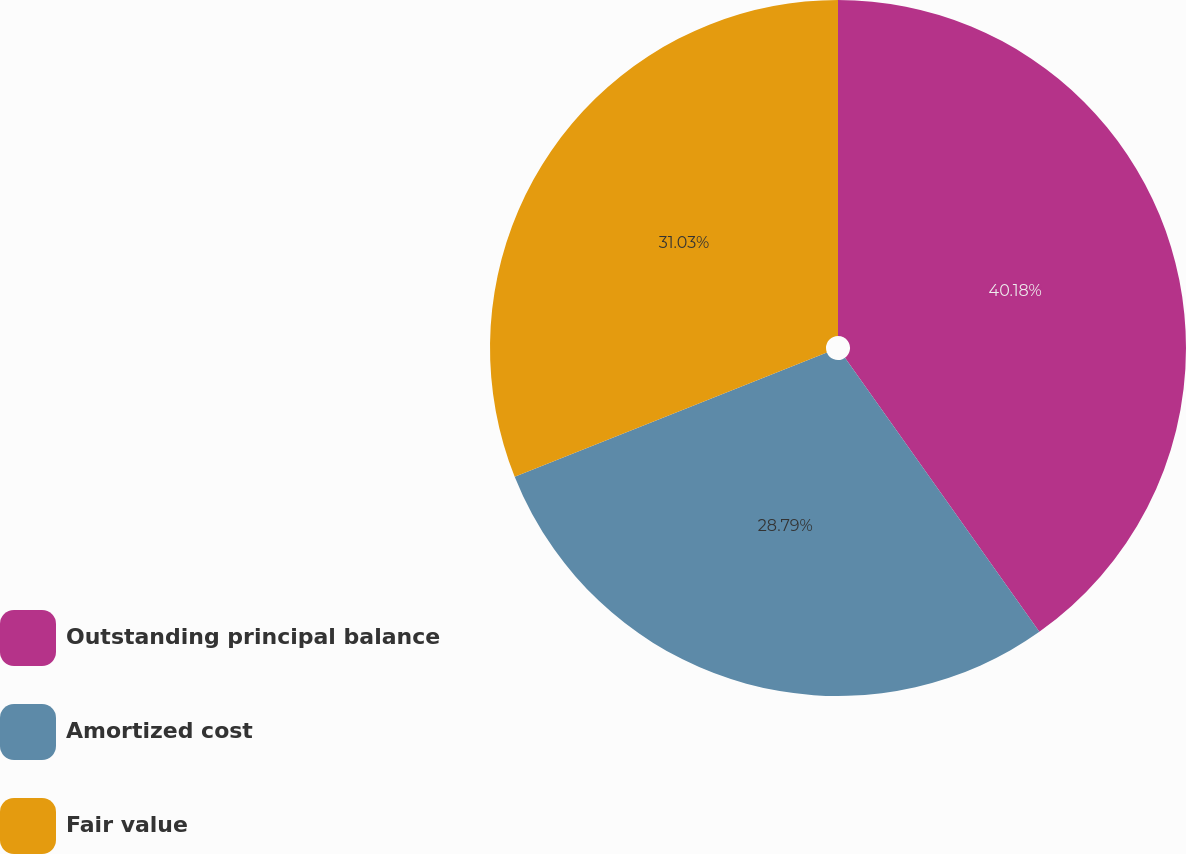Convert chart. <chart><loc_0><loc_0><loc_500><loc_500><pie_chart><fcel>Outstanding principal balance<fcel>Amortized cost<fcel>Fair value<nl><fcel>40.18%<fcel>28.79%<fcel>31.03%<nl></chart> 